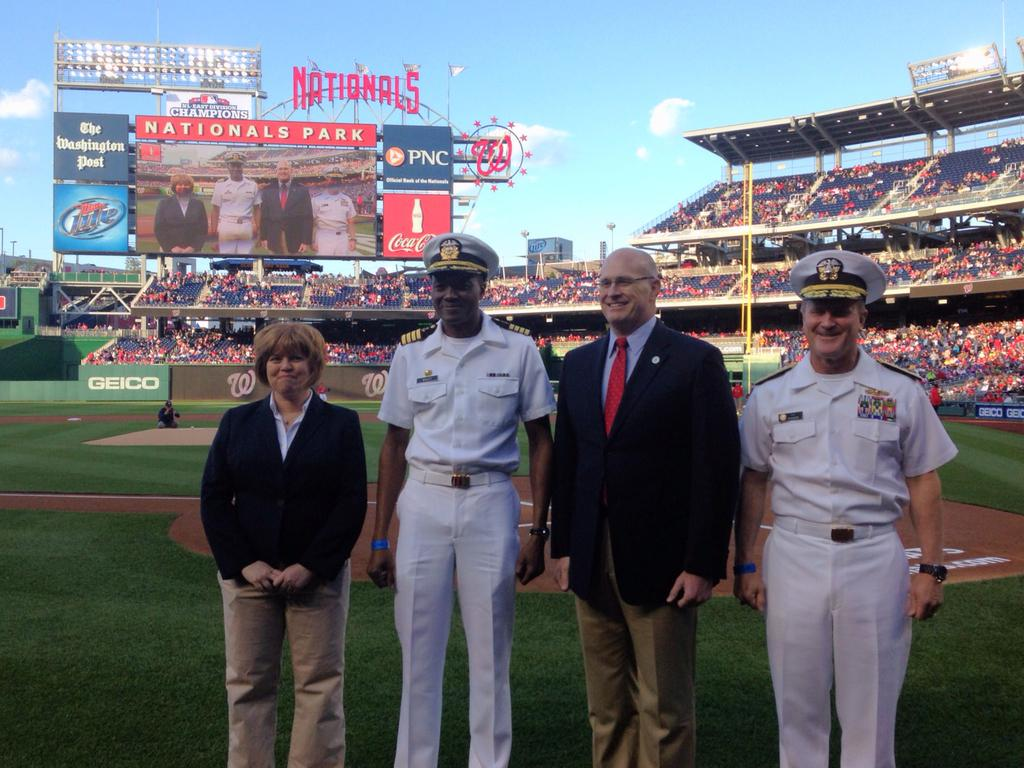<image>
Summarize the visual content of the image. Servicemen on the field for East Divison Champions 